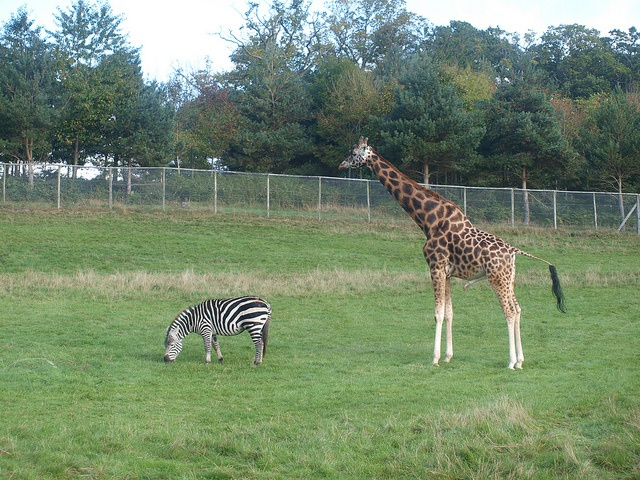Describe the objects in this image and their specific colors. I can see giraffe in white, gray, tan, and lightgray tones and zebra in white, black, gray, lightgray, and darkgray tones in this image. 